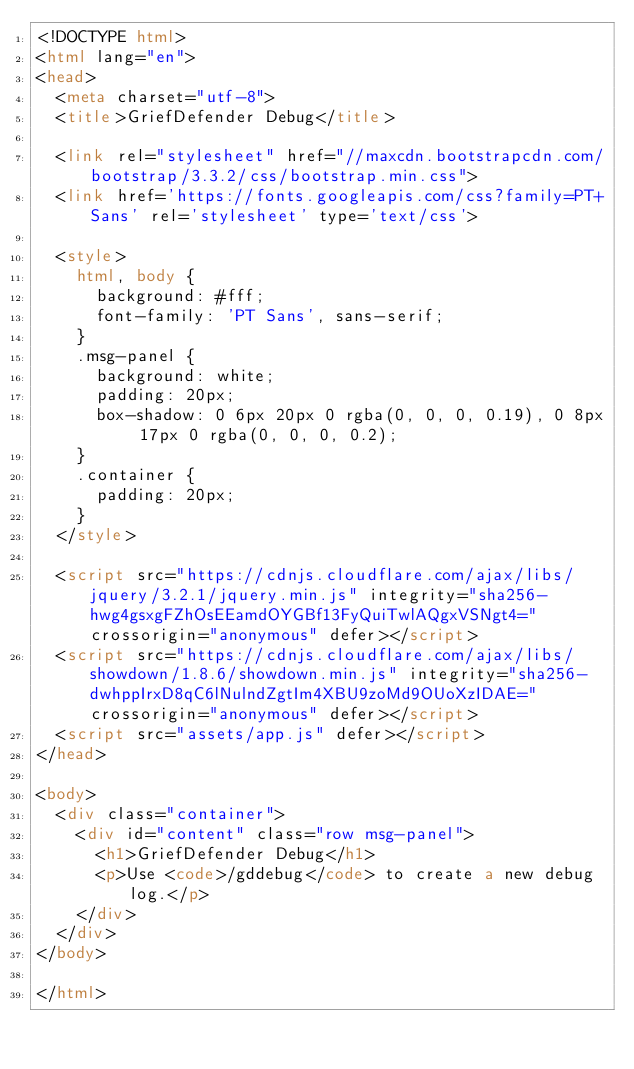<code> <loc_0><loc_0><loc_500><loc_500><_HTML_><!DOCTYPE html>
<html lang="en">
<head>
  <meta charset="utf-8">
  <title>GriefDefender Debug</title>

  <link rel="stylesheet" href="//maxcdn.bootstrapcdn.com/bootstrap/3.3.2/css/bootstrap.min.css">
  <link href='https://fonts.googleapis.com/css?family=PT+Sans' rel='stylesheet' type='text/css'>

  <style>
    html, body {
      background: #fff;
      font-family: 'PT Sans', sans-serif;
    }
    .msg-panel {
      background: white;
      padding: 20px;
      box-shadow: 0 6px 20px 0 rgba(0, 0, 0, 0.19), 0 8px 17px 0 rgba(0, 0, 0, 0.2);
    }
    .container {
      padding: 20px;
    }
  </style>

  <script src="https://cdnjs.cloudflare.com/ajax/libs/jquery/3.2.1/jquery.min.js" integrity="sha256-hwg4gsxgFZhOsEEamdOYGBf13FyQuiTwlAQgxVSNgt4=" crossorigin="anonymous" defer></script>
  <script src="https://cdnjs.cloudflare.com/ajax/libs/showdown/1.8.6/showdown.min.js" integrity="sha256-dwhppIrxD8qC6lNulndZgtIm4XBU9zoMd9OUoXzIDAE=" crossorigin="anonymous" defer></script>
  <script src="assets/app.js" defer></script>
</head>

<body>
  <div class="container">
    <div id="content" class="row msg-panel">
      <h1>GriefDefender Debug</h1>
      <p>Use <code>/gddebug</code> to create a new debug log.</p>
    </div>
  </div>
</body>

</html></code> 